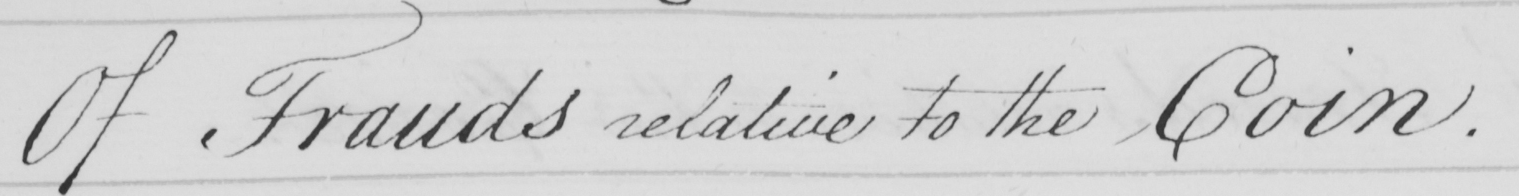Can you tell me what this handwritten text says? Of Frauds relative to the Coin . 